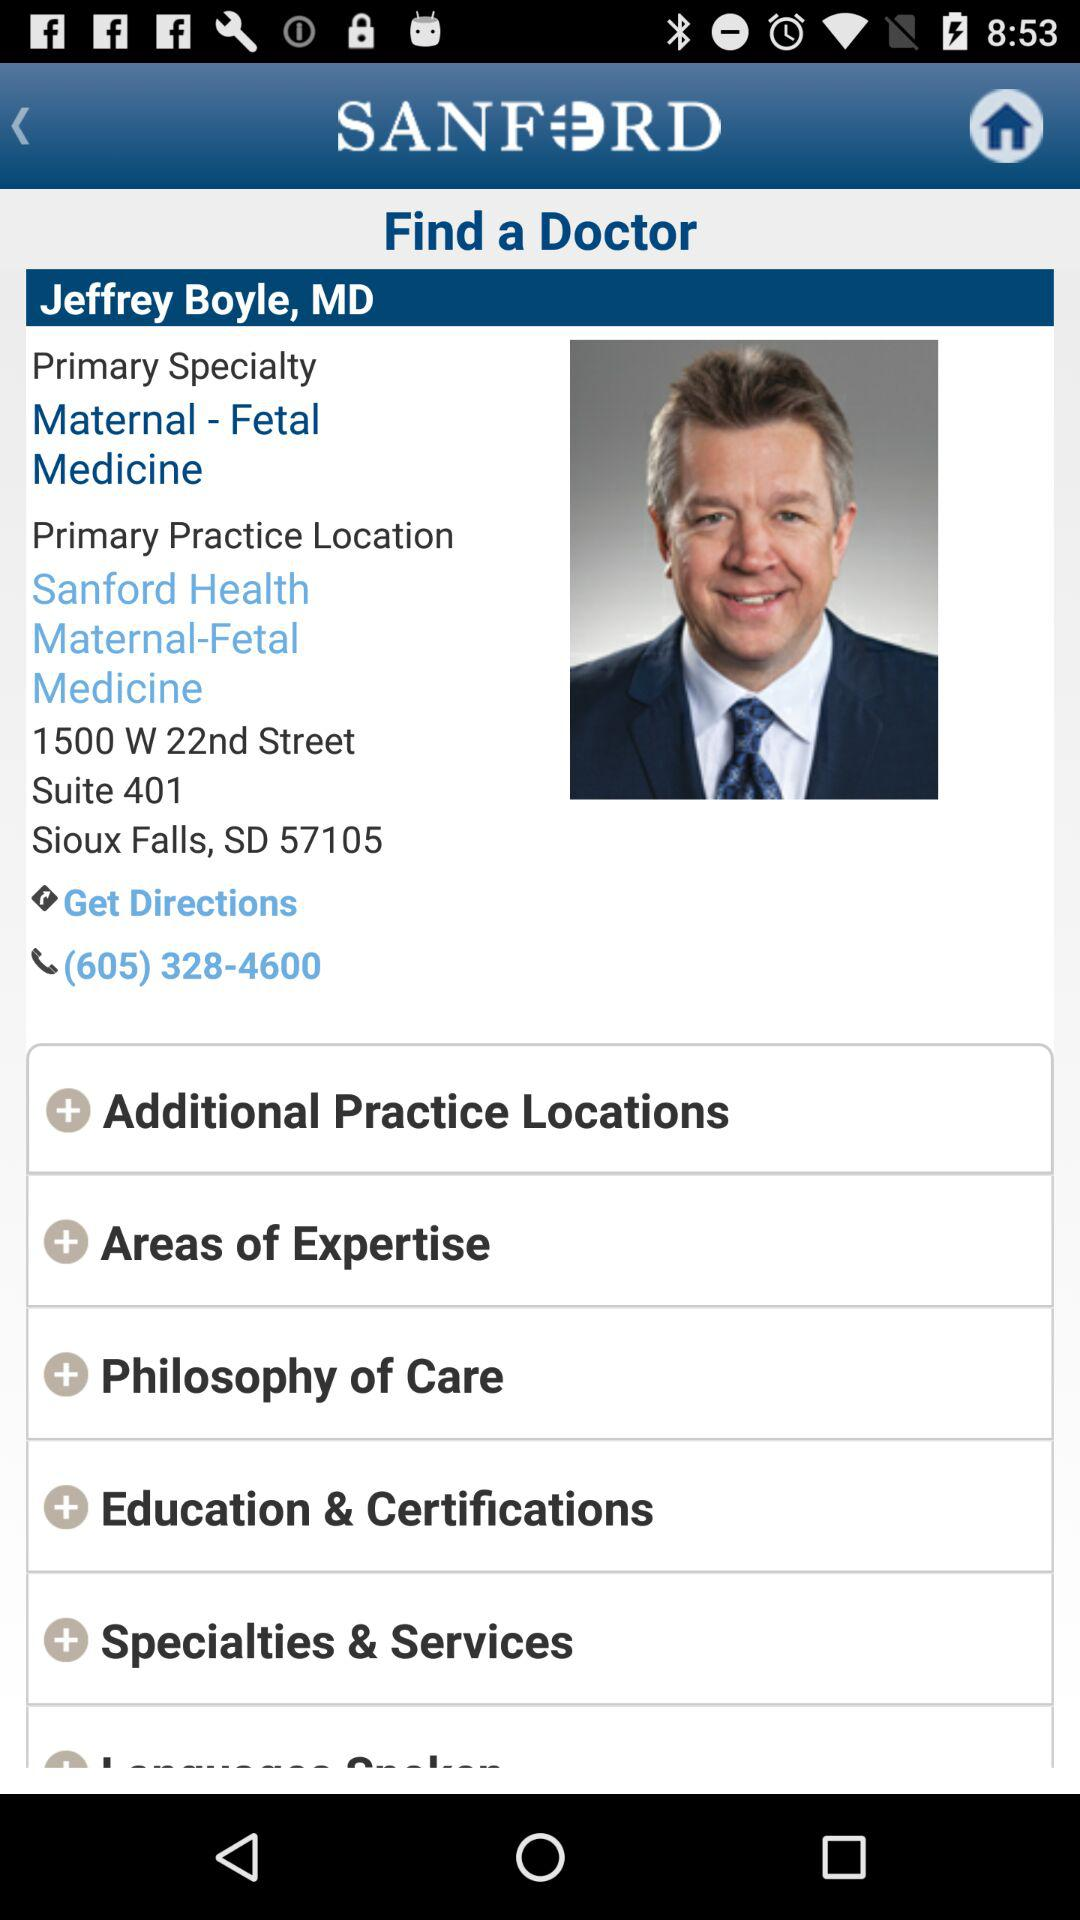What is the given phone number? The given phone number is (605) 328-4600. 